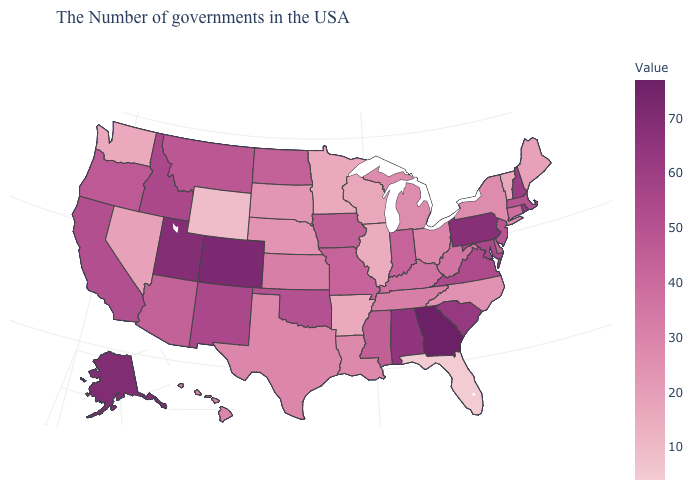Does Oregon have the lowest value in the USA?
Write a very short answer. No. Does New Hampshire have a lower value than Louisiana?
Concise answer only. No. Does Kansas have the highest value in the USA?
Short answer required. No. 